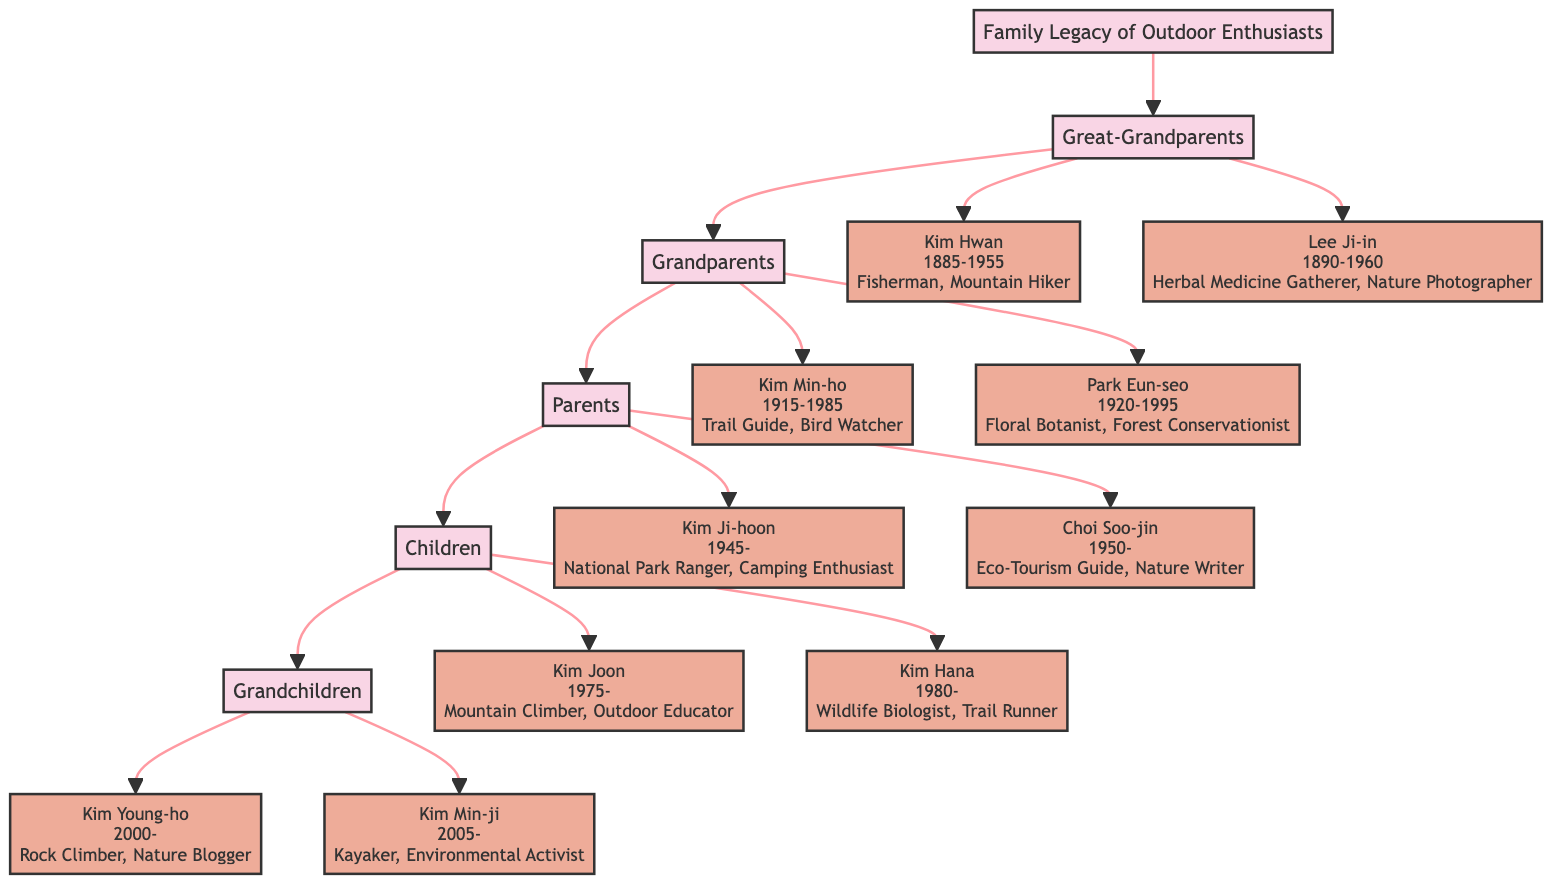What activities did Kim Hwan engage in? The diagram lists the activities of Kim Hwan, which are "Fisherman" and "Mountain Hiker."
Answer: Fisherman, Mountain Hiker How many generations are represented in the family tree? By counting the distinct generations shown in the diagram, we see five: Great-Grandparents, Grandparents, Parents, Children, and Grandchildren.
Answer: 5 Which member documented wildflower species? The information in the diagram states that Park Eun-seo documented species of wildflowers, specifically noting she documented "200 species of wildflowers in Seoraksan National Park."
Answer: Park Eun-seo What notable achievement does Kim Joon have? The diagram indicates that Kim Joon completed "the Seven Summits challenge in 2015," making this his notable achievement.
Answer: Completed the Seven Summits challenge in 2015 Who is the youngest grandchild in the family legacy? Within the Grandchildren generation, Kim Min-ji is indicated to have been born in 2005, making her the youngest grandchild.
Answer: Kim Min-ji How did Kim Ji-hoon contribute to Bukhansan National Park? According to the diagram, Kim Ji-hoon's notable achievement was "Implemented new safety protocols for Bukhansan National Park."
Answer: Implemented new safety protocols for Bukhansan National Park Which family member is a Nature Blogger? The diagram shows that Kim Young-ho is identified specifically as a "Nature Blogger" within the Grandchildren generation.
Answer: Kim Young-ho What relationship do Kim Joon and Kim Ji-hoon have? The flow of the diagram indicates that Kim Joon is the child of Kim Ji-hoon, associating them within the Parents and Children generations respectively.
Answer: Father-Son 